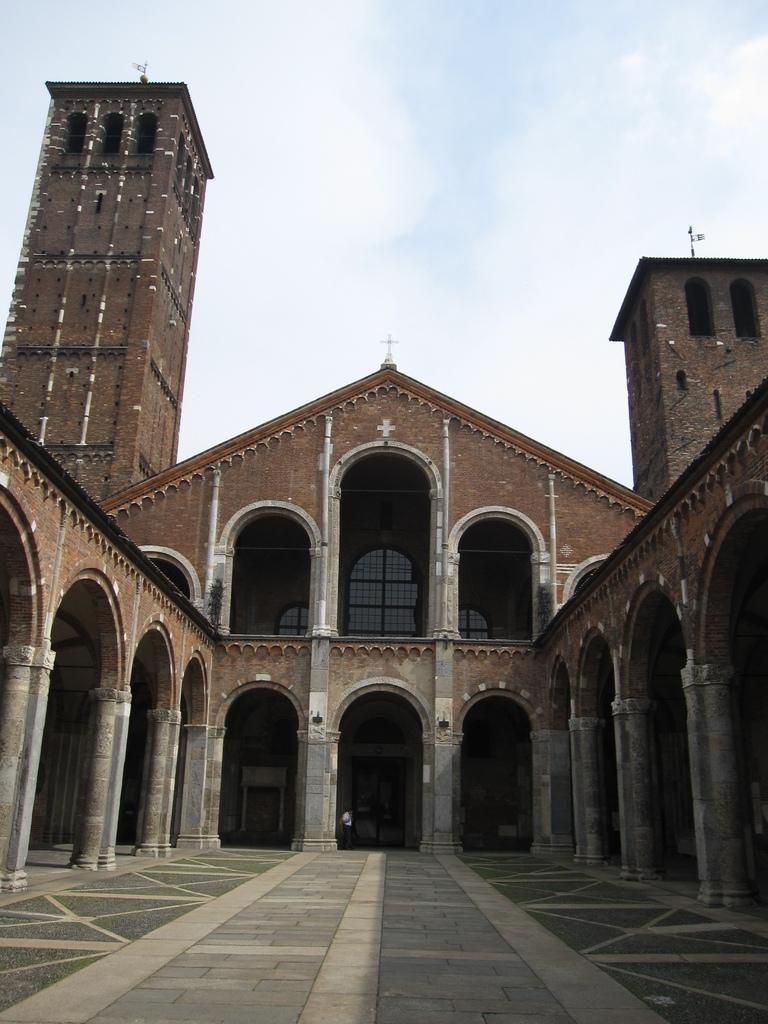What type of structure is present in the image? There is a building in the image. Can you describe any other elements in the image? Yes, there is a person in the image. What can be seen in the background of the image? The sky is visible in the background of the image. What type of curtain can be seen in the image? There is no curtain present in the image. How does the person in the image transport themselves to the location? The provided facts do not mention any transportation method, so it cannot be determined from the image. 